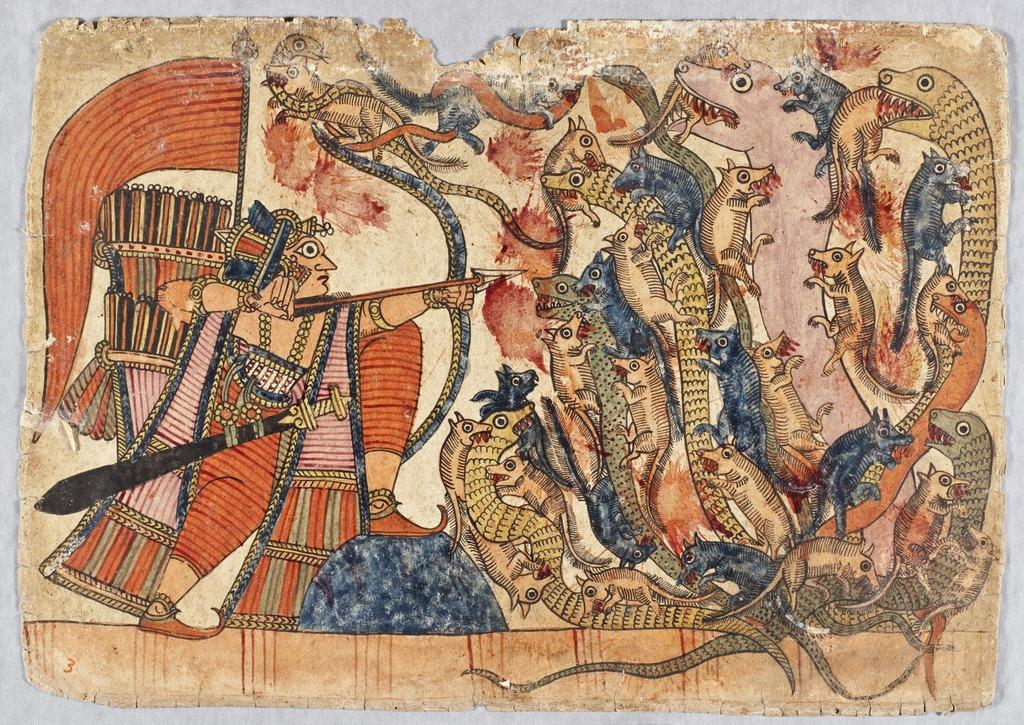What is the main subject of the painting? The painting contains a person. What type of creatures are present in the painting? There are snakes in the painting. What other living beings can be seen in the painting? There are animals in the painting. How many hands are visible in the painting? There is no mention of hands in the provided facts about the painting, so it cannot be determined from the image. What type of nerve is depicted in the painting? There is no mention of a nerve in the provided facts about the painting, so it cannot be determined from the image. 